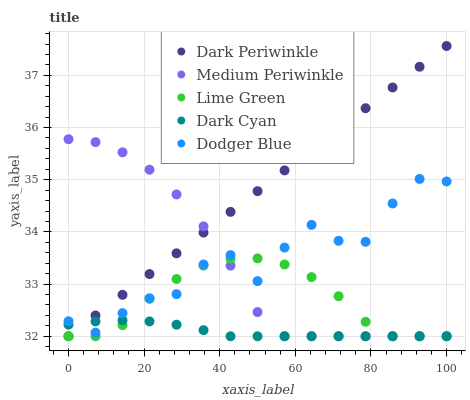Does Dark Cyan have the minimum area under the curve?
Answer yes or no. Yes. Does Dark Periwinkle have the maximum area under the curve?
Answer yes or no. Yes. Does Lime Green have the minimum area under the curve?
Answer yes or no. No. Does Lime Green have the maximum area under the curve?
Answer yes or no. No. Is Dark Periwinkle the smoothest?
Answer yes or no. Yes. Is Dodger Blue the roughest?
Answer yes or no. Yes. Is Lime Green the smoothest?
Answer yes or no. No. Is Lime Green the roughest?
Answer yes or no. No. Does Dark Cyan have the lowest value?
Answer yes or no. Yes. Does Dodger Blue have the lowest value?
Answer yes or no. No. Does Dark Periwinkle have the highest value?
Answer yes or no. Yes. Does Lime Green have the highest value?
Answer yes or no. No. Does Dodger Blue intersect Lime Green?
Answer yes or no. Yes. Is Dodger Blue less than Lime Green?
Answer yes or no. No. Is Dodger Blue greater than Lime Green?
Answer yes or no. No. 